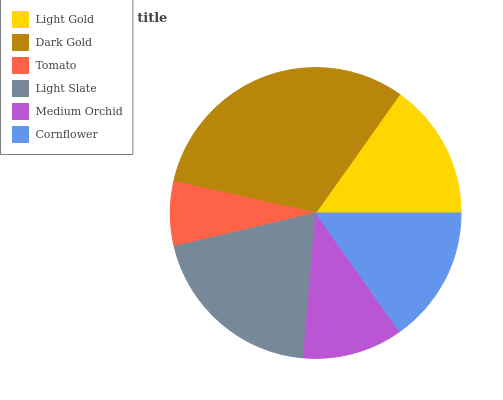Is Tomato the minimum?
Answer yes or no. Yes. Is Dark Gold the maximum?
Answer yes or no. Yes. Is Dark Gold the minimum?
Answer yes or no. No. Is Tomato the maximum?
Answer yes or no. No. Is Dark Gold greater than Tomato?
Answer yes or no. Yes. Is Tomato less than Dark Gold?
Answer yes or no. Yes. Is Tomato greater than Dark Gold?
Answer yes or no. No. Is Dark Gold less than Tomato?
Answer yes or no. No. Is Cornflower the high median?
Answer yes or no. Yes. Is Light Gold the low median?
Answer yes or no. Yes. Is Dark Gold the high median?
Answer yes or no. No. Is Cornflower the low median?
Answer yes or no. No. 